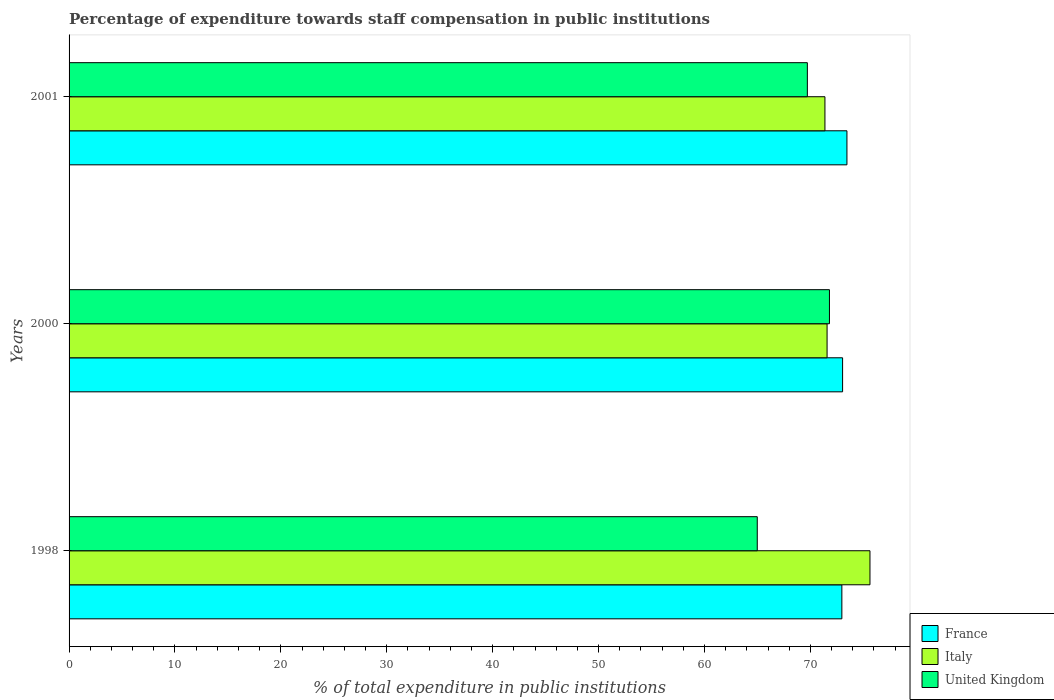Are the number of bars per tick equal to the number of legend labels?
Offer a terse response. Yes. What is the percentage of expenditure towards staff compensation in United Kingdom in 1998?
Provide a short and direct response. 64.98. Across all years, what is the maximum percentage of expenditure towards staff compensation in Italy?
Provide a succinct answer. 75.63. Across all years, what is the minimum percentage of expenditure towards staff compensation in France?
Provide a short and direct response. 72.97. In which year was the percentage of expenditure towards staff compensation in France maximum?
Ensure brevity in your answer.  2001. What is the total percentage of expenditure towards staff compensation in United Kingdom in the graph?
Give a very brief answer. 206.5. What is the difference between the percentage of expenditure towards staff compensation in United Kingdom in 1998 and that in 2001?
Your answer should be very brief. -4.73. What is the difference between the percentage of expenditure towards staff compensation in United Kingdom in 2000 and the percentage of expenditure towards staff compensation in France in 2001?
Your answer should be very brief. -1.65. What is the average percentage of expenditure towards staff compensation in France per year?
Your answer should be very brief. 73.16. In the year 2001, what is the difference between the percentage of expenditure towards staff compensation in United Kingdom and percentage of expenditure towards staff compensation in Italy?
Provide a succinct answer. -1.66. In how many years, is the percentage of expenditure towards staff compensation in United Kingdom greater than 72 %?
Provide a succinct answer. 0. What is the ratio of the percentage of expenditure towards staff compensation in Italy in 1998 to that in 2001?
Your response must be concise. 1.06. What is the difference between the highest and the second highest percentage of expenditure towards staff compensation in United Kingdom?
Offer a very short reply. 2.09. What is the difference between the highest and the lowest percentage of expenditure towards staff compensation in United Kingdom?
Offer a very short reply. 6.82. Is the sum of the percentage of expenditure towards staff compensation in United Kingdom in 1998 and 2000 greater than the maximum percentage of expenditure towards staff compensation in France across all years?
Your answer should be very brief. Yes. What does the 2nd bar from the top in 2001 represents?
Provide a short and direct response. Italy. How many bars are there?
Ensure brevity in your answer.  9. What is the difference between two consecutive major ticks on the X-axis?
Provide a succinct answer. 10. How many legend labels are there?
Make the answer very short. 3. What is the title of the graph?
Your answer should be very brief. Percentage of expenditure towards staff compensation in public institutions. Does "Angola" appear as one of the legend labels in the graph?
Keep it short and to the point. No. What is the label or title of the X-axis?
Keep it short and to the point. % of total expenditure in public institutions. What is the % of total expenditure in public institutions of France in 1998?
Provide a succinct answer. 72.97. What is the % of total expenditure in public institutions in Italy in 1998?
Make the answer very short. 75.63. What is the % of total expenditure in public institutions in United Kingdom in 1998?
Give a very brief answer. 64.98. What is the % of total expenditure in public institutions in France in 2000?
Your answer should be compact. 73.04. What is the % of total expenditure in public institutions of Italy in 2000?
Your answer should be compact. 71.58. What is the % of total expenditure in public institutions of United Kingdom in 2000?
Your answer should be compact. 71.8. What is the % of total expenditure in public institutions in France in 2001?
Give a very brief answer. 73.45. What is the % of total expenditure in public institutions in Italy in 2001?
Your answer should be very brief. 71.37. What is the % of total expenditure in public institutions in United Kingdom in 2001?
Ensure brevity in your answer.  69.72. Across all years, what is the maximum % of total expenditure in public institutions in France?
Offer a very short reply. 73.45. Across all years, what is the maximum % of total expenditure in public institutions in Italy?
Your response must be concise. 75.63. Across all years, what is the maximum % of total expenditure in public institutions in United Kingdom?
Provide a short and direct response. 71.8. Across all years, what is the minimum % of total expenditure in public institutions in France?
Offer a very short reply. 72.97. Across all years, what is the minimum % of total expenditure in public institutions in Italy?
Keep it short and to the point. 71.37. Across all years, what is the minimum % of total expenditure in public institutions in United Kingdom?
Give a very brief answer. 64.98. What is the total % of total expenditure in public institutions of France in the graph?
Provide a short and direct response. 219.47. What is the total % of total expenditure in public institutions of Italy in the graph?
Provide a succinct answer. 218.58. What is the total % of total expenditure in public institutions of United Kingdom in the graph?
Your answer should be compact. 206.5. What is the difference between the % of total expenditure in public institutions in France in 1998 and that in 2000?
Make the answer very short. -0.07. What is the difference between the % of total expenditure in public institutions of Italy in 1998 and that in 2000?
Offer a very short reply. 4.05. What is the difference between the % of total expenditure in public institutions of United Kingdom in 1998 and that in 2000?
Ensure brevity in your answer.  -6.82. What is the difference between the % of total expenditure in public institutions of France in 1998 and that in 2001?
Your response must be concise. -0.48. What is the difference between the % of total expenditure in public institutions in Italy in 1998 and that in 2001?
Provide a short and direct response. 4.25. What is the difference between the % of total expenditure in public institutions in United Kingdom in 1998 and that in 2001?
Provide a succinct answer. -4.73. What is the difference between the % of total expenditure in public institutions in France in 2000 and that in 2001?
Provide a short and direct response. -0.41. What is the difference between the % of total expenditure in public institutions in Italy in 2000 and that in 2001?
Offer a terse response. 0.2. What is the difference between the % of total expenditure in public institutions in United Kingdom in 2000 and that in 2001?
Keep it short and to the point. 2.09. What is the difference between the % of total expenditure in public institutions of France in 1998 and the % of total expenditure in public institutions of Italy in 2000?
Your response must be concise. 1.4. What is the difference between the % of total expenditure in public institutions in France in 1998 and the % of total expenditure in public institutions in United Kingdom in 2000?
Provide a succinct answer. 1.17. What is the difference between the % of total expenditure in public institutions of Italy in 1998 and the % of total expenditure in public institutions of United Kingdom in 2000?
Ensure brevity in your answer.  3.83. What is the difference between the % of total expenditure in public institutions of France in 1998 and the % of total expenditure in public institutions of Italy in 2001?
Your answer should be very brief. 1.6. What is the difference between the % of total expenditure in public institutions of France in 1998 and the % of total expenditure in public institutions of United Kingdom in 2001?
Offer a terse response. 3.26. What is the difference between the % of total expenditure in public institutions of Italy in 1998 and the % of total expenditure in public institutions of United Kingdom in 2001?
Keep it short and to the point. 5.91. What is the difference between the % of total expenditure in public institutions in France in 2000 and the % of total expenditure in public institutions in Italy in 2001?
Offer a very short reply. 1.67. What is the difference between the % of total expenditure in public institutions of France in 2000 and the % of total expenditure in public institutions of United Kingdom in 2001?
Offer a very short reply. 3.33. What is the difference between the % of total expenditure in public institutions in Italy in 2000 and the % of total expenditure in public institutions in United Kingdom in 2001?
Your answer should be very brief. 1.86. What is the average % of total expenditure in public institutions of France per year?
Ensure brevity in your answer.  73.16. What is the average % of total expenditure in public institutions of Italy per year?
Provide a short and direct response. 72.86. What is the average % of total expenditure in public institutions of United Kingdom per year?
Offer a terse response. 68.83. In the year 1998, what is the difference between the % of total expenditure in public institutions of France and % of total expenditure in public institutions of Italy?
Give a very brief answer. -2.65. In the year 1998, what is the difference between the % of total expenditure in public institutions of France and % of total expenditure in public institutions of United Kingdom?
Your answer should be very brief. 7.99. In the year 1998, what is the difference between the % of total expenditure in public institutions in Italy and % of total expenditure in public institutions in United Kingdom?
Provide a short and direct response. 10.64. In the year 2000, what is the difference between the % of total expenditure in public institutions of France and % of total expenditure in public institutions of Italy?
Your answer should be compact. 1.46. In the year 2000, what is the difference between the % of total expenditure in public institutions of France and % of total expenditure in public institutions of United Kingdom?
Your answer should be very brief. 1.24. In the year 2000, what is the difference between the % of total expenditure in public institutions of Italy and % of total expenditure in public institutions of United Kingdom?
Ensure brevity in your answer.  -0.22. In the year 2001, what is the difference between the % of total expenditure in public institutions in France and % of total expenditure in public institutions in Italy?
Offer a very short reply. 2.08. In the year 2001, what is the difference between the % of total expenditure in public institutions of France and % of total expenditure in public institutions of United Kingdom?
Keep it short and to the point. 3.74. In the year 2001, what is the difference between the % of total expenditure in public institutions of Italy and % of total expenditure in public institutions of United Kingdom?
Your answer should be compact. 1.66. What is the ratio of the % of total expenditure in public institutions in France in 1998 to that in 2000?
Your answer should be compact. 1. What is the ratio of the % of total expenditure in public institutions of Italy in 1998 to that in 2000?
Provide a short and direct response. 1.06. What is the ratio of the % of total expenditure in public institutions in United Kingdom in 1998 to that in 2000?
Offer a terse response. 0.91. What is the ratio of the % of total expenditure in public institutions of France in 1998 to that in 2001?
Provide a short and direct response. 0.99. What is the ratio of the % of total expenditure in public institutions in Italy in 1998 to that in 2001?
Give a very brief answer. 1.06. What is the ratio of the % of total expenditure in public institutions in United Kingdom in 1998 to that in 2001?
Offer a very short reply. 0.93. What is the ratio of the % of total expenditure in public institutions of France in 2000 to that in 2001?
Your answer should be compact. 0.99. What is the ratio of the % of total expenditure in public institutions in United Kingdom in 2000 to that in 2001?
Your answer should be compact. 1.03. What is the difference between the highest and the second highest % of total expenditure in public institutions in France?
Make the answer very short. 0.41. What is the difference between the highest and the second highest % of total expenditure in public institutions in Italy?
Your answer should be very brief. 4.05. What is the difference between the highest and the second highest % of total expenditure in public institutions in United Kingdom?
Your response must be concise. 2.09. What is the difference between the highest and the lowest % of total expenditure in public institutions in France?
Provide a succinct answer. 0.48. What is the difference between the highest and the lowest % of total expenditure in public institutions in Italy?
Your answer should be very brief. 4.25. What is the difference between the highest and the lowest % of total expenditure in public institutions of United Kingdom?
Keep it short and to the point. 6.82. 